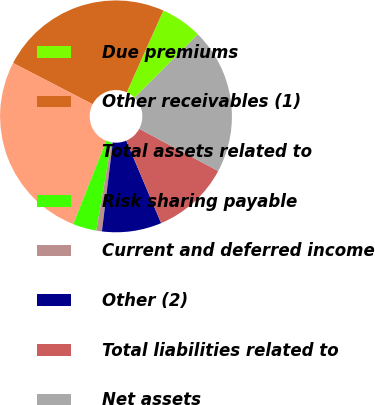Convert chart. <chart><loc_0><loc_0><loc_500><loc_500><pie_chart><fcel>Due premiums<fcel>Other receivables (1)<fcel>Total assets related to<fcel>Risk sharing payable<fcel>Current and deferred income<fcel>Other (2)<fcel>Total liabilities related to<fcel>Net assets<nl><fcel>5.8%<fcel>24.09%<fcel>26.6%<fcel>3.29%<fcel>0.78%<fcel>8.31%<fcel>10.82%<fcel>20.32%<nl></chart> 